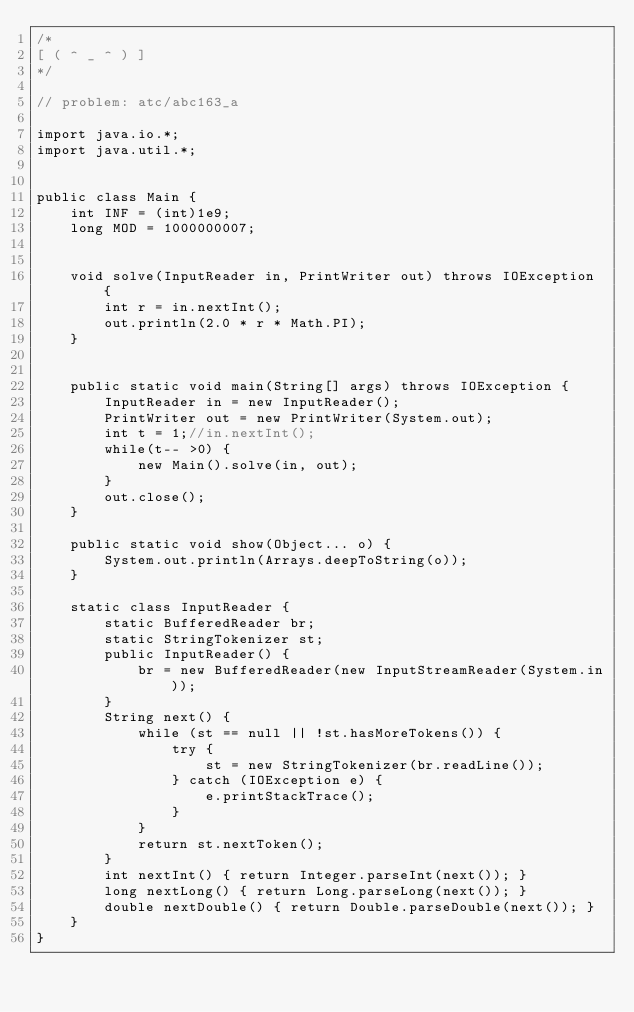Convert code to text. <code><loc_0><loc_0><loc_500><loc_500><_C_>/*
[ ( ^ _ ^ ) ]
*/

// problem: atc/abc163_a

import java.io.*;
import java.util.*;


public class Main {
    int INF = (int)1e9;
    long MOD = 1000000007;


    void solve(InputReader in, PrintWriter out) throws IOException {
        int r = in.nextInt();
        out.println(2.0 * r * Math.PI);
    }
    

    public static void main(String[] args) throws IOException {
        InputReader in = new InputReader();
        PrintWriter out = new PrintWriter(System.out);
        int t = 1;//in.nextInt();
        while(t-- >0) {
            new Main().solve(in, out);
        }
        out.close();
    }
    
    public static void show(Object... o) {
        System.out.println(Arrays.deepToString(o));
    }
    
    static class InputReader {
        static BufferedReader br;
        static StringTokenizer st;
        public InputReader() {
            br = new BufferedReader(new InputStreamReader(System.in));
        }
        String next() {
            while (st == null || !st.hasMoreTokens()) {
                try {
                    st = new StringTokenizer(br.readLine());
                } catch (IOException e) {
                    e.printStackTrace();
                }
            }
            return st.nextToken();
        }
        int nextInt() { return Integer.parseInt(next()); }
        long nextLong() { return Long.parseLong(next()); }
        double nextDouble() { return Double.parseDouble(next()); }
    }
}</code> 